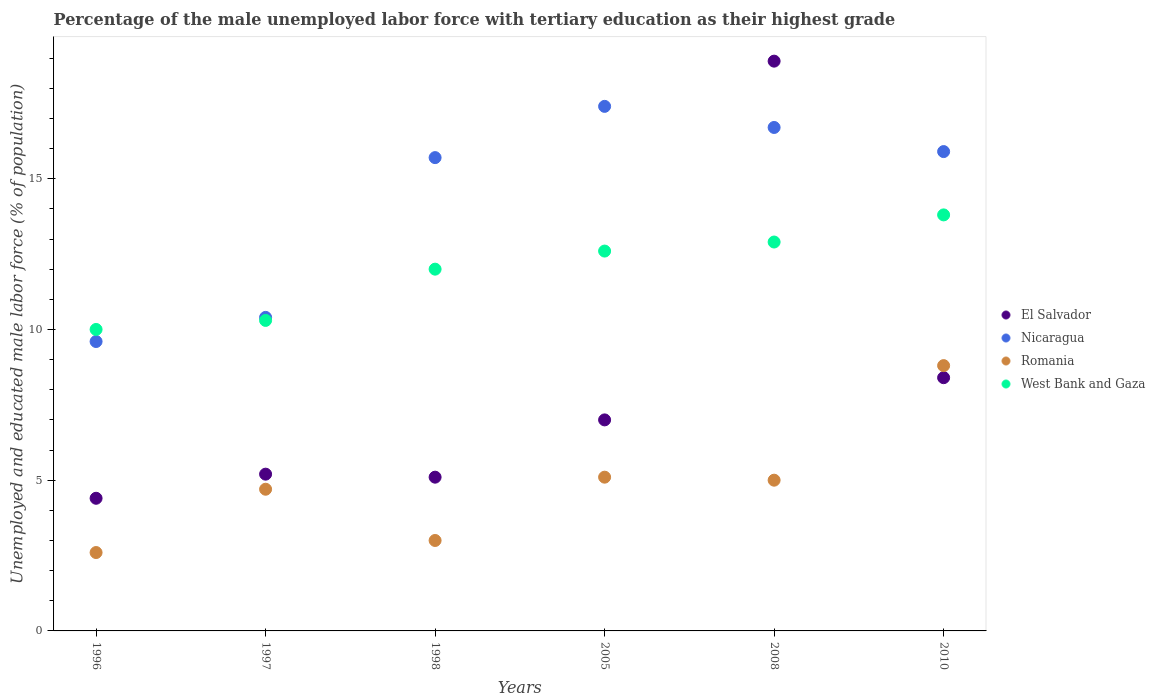How many different coloured dotlines are there?
Give a very brief answer. 4. What is the percentage of the unemployed male labor force with tertiary education in El Salvador in 2008?
Your response must be concise. 18.9. Across all years, what is the maximum percentage of the unemployed male labor force with tertiary education in Romania?
Give a very brief answer. 8.8. Across all years, what is the minimum percentage of the unemployed male labor force with tertiary education in El Salvador?
Make the answer very short. 4.4. In which year was the percentage of the unemployed male labor force with tertiary education in Romania minimum?
Your answer should be compact. 1996. What is the total percentage of the unemployed male labor force with tertiary education in Nicaragua in the graph?
Offer a very short reply. 85.7. What is the difference between the percentage of the unemployed male labor force with tertiary education in Romania in 1996 and that in 1998?
Provide a short and direct response. -0.4. What is the difference between the percentage of the unemployed male labor force with tertiary education in Nicaragua in 1997 and the percentage of the unemployed male labor force with tertiary education in El Salvador in 2005?
Your response must be concise. 3.4. What is the average percentage of the unemployed male labor force with tertiary education in West Bank and Gaza per year?
Provide a short and direct response. 11.93. In the year 1998, what is the difference between the percentage of the unemployed male labor force with tertiary education in West Bank and Gaza and percentage of the unemployed male labor force with tertiary education in El Salvador?
Offer a very short reply. 6.9. What is the ratio of the percentage of the unemployed male labor force with tertiary education in West Bank and Gaza in 1998 to that in 2010?
Offer a terse response. 0.87. Is the percentage of the unemployed male labor force with tertiary education in West Bank and Gaza in 1998 less than that in 2005?
Your answer should be compact. Yes. Is the difference between the percentage of the unemployed male labor force with tertiary education in West Bank and Gaza in 1998 and 2008 greater than the difference between the percentage of the unemployed male labor force with tertiary education in El Salvador in 1998 and 2008?
Give a very brief answer. Yes. What is the difference between the highest and the second highest percentage of the unemployed male labor force with tertiary education in Nicaragua?
Your response must be concise. 0.7. What is the difference between the highest and the lowest percentage of the unemployed male labor force with tertiary education in Nicaragua?
Your response must be concise. 7.8. Is the sum of the percentage of the unemployed male labor force with tertiary education in Romania in 1996 and 2010 greater than the maximum percentage of the unemployed male labor force with tertiary education in West Bank and Gaza across all years?
Give a very brief answer. No. Is it the case that in every year, the sum of the percentage of the unemployed male labor force with tertiary education in Nicaragua and percentage of the unemployed male labor force with tertiary education in Romania  is greater than the percentage of the unemployed male labor force with tertiary education in West Bank and Gaza?
Your response must be concise. Yes. How many dotlines are there?
Make the answer very short. 4. How many years are there in the graph?
Ensure brevity in your answer.  6. What is the difference between two consecutive major ticks on the Y-axis?
Your answer should be very brief. 5. Does the graph contain any zero values?
Your answer should be very brief. No. Does the graph contain grids?
Keep it short and to the point. No. Where does the legend appear in the graph?
Offer a terse response. Center right. What is the title of the graph?
Make the answer very short. Percentage of the male unemployed labor force with tertiary education as their highest grade. What is the label or title of the X-axis?
Offer a terse response. Years. What is the label or title of the Y-axis?
Provide a succinct answer. Unemployed and educated male labor force (% of population). What is the Unemployed and educated male labor force (% of population) of El Salvador in 1996?
Your response must be concise. 4.4. What is the Unemployed and educated male labor force (% of population) of Nicaragua in 1996?
Provide a short and direct response. 9.6. What is the Unemployed and educated male labor force (% of population) in Romania in 1996?
Your answer should be very brief. 2.6. What is the Unemployed and educated male labor force (% of population) in El Salvador in 1997?
Offer a terse response. 5.2. What is the Unemployed and educated male labor force (% of population) of Nicaragua in 1997?
Your answer should be compact. 10.4. What is the Unemployed and educated male labor force (% of population) in Romania in 1997?
Your answer should be very brief. 4.7. What is the Unemployed and educated male labor force (% of population) of West Bank and Gaza in 1997?
Provide a short and direct response. 10.3. What is the Unemployed and educated male labor force (% of population) in El Salvador in 1998?
Keep it short and to the point. 5.1. What is the Unemployed and educated male labor force (% of population) of Nicaragua in 1998?
Ensure brevity in your answer.  15.7. What is the Unemployed and educated male labor force (% of population) in Nicaragua in 2005?
Provide a succinct answer. 17.4. What is the Unemployed and educated male labor force (% of population) in Romania in 2005?
Your answer should be very brief. 5.1. What is the Unemployed and educated male labor force (% of population) in West Bank and Gaza in 2005?
Offer a very short reply. 12.6. What is the Unemployed and educated male labor force (% of population) of El Salvador in 2008?
Offer a terse response. 18.9. What is the Unemployed and educated male labor force (% of population) in Nicaragua in 2008?
Make the answer very short. 16.7. What is the Unemployed and educated male labor force (% of population) of Romania in 2008?
Your answer should be compact. 5. What is the Unemployed and educated male labor force (% of population) in West Bank and Gaza in 2008?
Keep it short and to the point. 12.9. What is the Unemployed and educated male labor force (% of population) in El Salvador in 2010?
Offer a terse response. 8.4. What is the Unemployed and educated male labor force (% of population) in Nicaragua in 2010?
Offer a very short reply. 15.9. What is the Unemployed and educated male labor force (% of population) in Romania in 2010?
Provide a short and direct response. 8.8. What is the Unemployed and educated male labor force (% of population) of West Bank and Gaza in 2010?
Offer a very short reply. 13.8. Across all years, what is the maximum Unemployed and educated male labor force (% of population) of El Salvador?
Give a very brief answer. 18.9. Across all years, what is the maximum Unemployed and educated male labor force (% of population) in Nicaragua?
Provide a short and direct response. 17.4. Across all years, what is the maximum Unemployed and educated male labor force (% of population) in Romania?
Keep it short and to the point. 8.8. Across all years, what is the maximum Unemployed and educated male labor force (% of population) in West Bank and Gaza?
Provide a short and direct response. 13.8. Across all years, what is the minimum Unemployed and educated male labor force (% of population) in El Salvador?
Your answer should be very brief. 4.4. Across all years, what is the minimum Unemployed and educated male labor force (% of population) in Nicaragua?
Keep it short and to the point. 9.6. Across all years, what is the minimum Unemployed and educated male labor force (% of population) in Romania?
Provide a succinct answer. 2.6. Across all years, what is the minimum Unemployed and educated male labor force (% of population) in West Bank and Gaza?
Your response must be concise. 10. What is the total Unemployed and educated male labor force (% of population) of Nicaragua in the graph?
Give a very brief answer. 85.7. What is the total Unemployed and educated male labor force (% of population) in Romania in the graph?
Make the answer very short. 29.2. What is the total Unemployed and educated male labor force (% of population) in West Bank and Gaza in the graph?
Your answer should be compact. 71.6. What is the difference between the Unemployed and educated male labor force (% of population) in El Salvador in 1996 and that in 1997?
Ensure brevity in your answer.  -0.8. What is the difference between the Unemployed and educated male labor force (% of population) of Romania in 1996 and that in 1997?
Offer a terse response. -2.1. What is the difference between the Unemployed and educated male labor force (% of population) of West Bank and Gaza in 1996 and that in 1997?
Offer a very short reply. -0.3. What is the difference between the Unemployed and educated male labor force (% of population) in El Salvador in 1996 and that in 1998?
Your answer should be compact. -0.7. What is the difference between the Unemployed and educated male labor force (% of population) of Nicaragua in 1996 and that in 1998?
Your answer should be very brief. -6.1. What is the difference between the Unemployed and educated male labor force (% of population) in Romania in 1996 and that in 1998?
Offer a very short reply. -0.4. What is the difference between the Unemployed and educated male labor force (% of population) in West Bank and Gaza in 1996 and that in 1998?
Offer a very short reply. -2. What is the difference between the Unemployed and educated male labor force (% of population) in El Salvador in 1996 and that in 2005?
Provide a short and direct response. -2.6. What is the difference between the Unemployed and educated male labor force (% of population) in El Salvador in 1996 and that in 2008?
Your response must be concise. -14.5. What is the difference between the Unemployed and educated male labor force (% of population) of Nicaragua in 1996 and that in 2008?
Offer a very short reply. -7.1. What is the difference between the Unemployed and educated male labor force (% of population) of West Bank and Gaza in 1996 and that in 2008?
Give a very brief answer. -2.9. What is the difference between the Unemployed and educated male labor force (% of population) in El Salvador in 1997 and that in 1998?
Your answer should be compact. 0.1. What is the difference between the Unemployed and educated male labor force (% of population) in Nicaragua in 1997 and that in 1998?
Ensure brevity in your answer.  -5.3. What is the difference between the Unemployed and educated male labor force (% of population) of Romania in 1997 and that in 1998?
Your answer should be very brief. 1.7. What is the difference between the Unemployed and educated male labor force (% of population) of West Bank and Gaza in 1997 and that in 1998?
Your response must be concise. -1.7. What is the difference between the Unemployed and educated male labor force (% of population) in El Salvador in 1997 and that in 2005?
Make the answer very short. -1.8. What is the difference between the Unemployed and educated male labor force (% of population) of El Salvador in 1997 and that in 2008?
Provide a succinct answer. -13.7. What is the difference between the Unemployed and educated male labor force (% of population) in West Bank and Gaza in 1997 and that in 2008?
Give a very brief answer. -2.6. What is the difference between the Unemployed and educated male labor force (% of population) of Nicaragua in 1997 and that in 2010?
Your answer should be compact. -5.5. What is the difference between the Unemployed and educated male labor force (% of population) in West Bank and Gaza in 1997 and that in 2010?
Provide a succinct answer. -3.5. What is the difference between the Unemployed and educated male labor force (% of population) in El Salvador in 1998 and that in 2008?
Offer a terse response. -13.8. What is the difference between the Unemployed and educated male labor force (% of population) in West Bank and Gaza in 1998 and that in 2008?
Provide a short and direct response. -0.9. What is the difference between the Unemployed and educated male labor force (% of population) of El Salvador in 1998 and that in 2010?
Offer a terse response. -3.3. What is the difference between the Unemployed and educated male labor force (% of population) of El Salvador in 2005 and that in 2008?
Ensure brevity in your answer.  -11.9. What is the difference between the Unemployed and educated male labor force (% of population) in Romania in 2005 and that in 2010?
Offer a terse response. -3.7. What is the difference between the Unemployed and educated male labor force (% of population) of Nicaragua in 2008 and that in 2010?
Give a very brief answer. 0.8. What is the difference between the Unemployed and educated male labor force (% of population) of Romania in 2008 and that in 2010?
Your answer should be compact. -3.8. What is the difference between the Unemployed and educated male labor force (% of population) of El Salvador in 1996 and the Unemployed and educated male labor force (% of population) of Nicaragua in 1997?
Offer a very short reply. -6. What is the difference between the Unemployed and educated male labor force (% of population) in El Salvador in 1996 and the Unemployed and educated male labor force (% of population) in West Bank and Gaza in 1997?
Ensure brevity in your answer.  -5.9. What is the difference between the Unemployed and educated male labor force (% of population) in Nicaragua in 1996 and the Unemployed and educated male labor force (% of population) in Romania in 1997?
Your response must be concise. 4.9. What is the difference between the Unemployed and educated male labor force (% of population) in El Salvador in 1996 and the Unemployed and educated male labor force (% of population) in Nicaragua in 1998?
Ensure brevity in your answer.  -11.3. What is the difference between the Unemployed and educated male labor force (% of population) in El Salvador in 1996 and the Unemployed and educated male labor force (% of population) in Romania in 1998?
Your response must be concise. 1.4. What is the difference between the Unemployed and educated male labor force (% of population) in Nicaragua in 1996 and the Unemployed and educated male labor force (% of population) in Romania in 1998?
Offer a terse response. 6.6. What is the difference between the Unemployed and educated male labor force (% of population) of Romania in 1996 and the Unemployed and educated male labor force (% of population) of West Bank and Gaza in 1998?
Provide a succinct answer. -9.4. What is the difference between the Unemployed and educated male labor force (% of population) in El Salvador in 1996 and the Unemployed and educated male labor force (% of population) in Romania in 2008?
Your response must be concise. -0.6. What is the difference between the Unemployed and educated male labor force (% of population) in El Salvador in 1996 and the Unemployed and educated male labor force (% of population) in West Bank and Gaza in 2008?
Offer a very short reply. -8.5. What is the difference between the Unemployed and educated male labor force (% of population) in Romania in 1996 and the Unemployed and educated male labor force (% of population) in West Bank and Gaza in 2008?
Provide a succinct answer. -10.3. What is the difference between the Unemployed and educated male labor force (% of population) in El Salvador in 1996 and the Unemployed and educated male labor force (% of population) in Nicaragua in 2010?
Provide a succinct answer. -11.5. What is the difference between the Unemployed and educated male labor force (% of population) in El Salvador in 1996 and the Unemployed and educated male labor force (% of population) in Romania in 2010?
Make the answer very short. -4.4. What is the difference between the Unemployed and educated male labor force (% of population) of Nicaragua in 1996 and the Unemployed and educated male labor force (% of population) of West Bank and Gaza in 2010?
Provide a succinct answer. -4.2. What is the difference between the Unemployed and educated male labor force (% of population) in El Salvador in 1997 and the Unemployed and educated male labor force (% of population) in Romania in 1998?
Keep it short and to the point. 2.2. What is the difference between the Unemployed and educated male labor force (% of population) in El Salvador in 1997 and the Unemployed and educated male labor force (% of population) in West Bank and Gaza in 1998?
Ensure brevity in your answer.  -6.8. What is the difference between the Unemployed and educated male labor force (% of population) in Nicaragua in 1997 and the Unemployed and educated male labor force (% of population) in Romania in 1998?
Offer a very short reply. 7.4. What is the difference between the Unemployed and educated male labor force (% of population) in El Salvador in 1997 and the Unemployed and educated male labor force (% of population) in Romania in 2005?
Offer a very short reply. 0.1. What is the difference between the Unemployed and educated male labor force (% of population) of El Salvador in 1997 and the Unemployed and educated male labor force (% of population) of West Bank and Gaza in 2005?
Offer a very short reply. -7.4. What is the difference between the Unemployed and educated male labor force (% of population) of El Salvador in 1997 and the Unemployed and educated male labor force (% of population) of Nicaragua in 2008?
Make the answer very short. -11.5. What is the difference between the Unemployed and educated male labor force (% of population) of El Salvador in 1997 and the Unemployed and educated male labor force (% of population) of Romania in 2008?
Offer a terse response. 0.2. What is the difference between the Unemployed and educated male labor force (% of population) in El Salvador in 1997 and the Unemployed and educated male labor force (% of population) in West Bank and Gaza in 2008?
Make the answer very short. -7.7. What is the difference between the Unemployed and educated male labor force (% of population) of Nicaragua in 1997 and the Unemployed and educated male labor force (% of population) of Romania in 2008?
Provide a succinct answer. 5.4. What is the difference between the Unemployed and educated male labor force (% of population) in El Salvador in 1997 and the Unemployed and educated male labor force (% of population) in Romania in 2010?
Offer a terse response. -3.6. What is the difference between the Unemployed and educated male labor force (% of population) in El Salvador in 1998 and the Unemployed and educated male labor force (% of population) in Nicaragua in 2005?
Your answer should be compact. -12.3. What is the difference between the Unemployed and educated male labor force (% of population) in El Salvador in 1998 and the Unemployed and educated male labor force (% of population) in Romania in 2008?
Your response must be concise. 0.1. What is the difference between the Unemployed and educated male labor force (% of population) of El Salvador in 1998 and the Unemployed and educated male labor force (% of population) of West Bank and Gaza in 2008?
Ensure brevity in your answer.  -7.8. What is the difference between the Unemployed and educated male labor force (% of population) of Romania in 1998 and the Unemployed and educated male labor force (% of population) of West Bank and Gaza in 2008?
Ensure brevity in your answer.  -9.9. What is the difference between the Unemployed and educated male labor force (% of population) of El Salvador in 1998 and the Unemployed and educated male labor force (% of population) of West Bank and Gaza in 2010?
Provide a succinct answer. -8.7. What is the difference between the Unemployed and educated male labor force (% of population) in Nicaragua in 1998 and the Unemployed and educated male labor force (% of population) in Romania in 2010?
Ensure brevity in your answer.  6.9. What is the difference between the Unemployed and educated male labor force (% of population) of Nicaragua in 1998 and the Unemployed and educated male labor force (% of population) of West Bank and Gaza in 2010?
Offer a very short reply. 1.9. What is the difference between the Unemployed and educated male labor force (% of population) in El Salvador in 2005 and the Unemployed and educated male labor force (% of population) in Nicaragua in 2008?
Your answer should be compact. -9.7. What is the difference between the Unemployed and educated male labor force (% of population) of Nicaragua in 2005 and the Unemployed and educated male labor force (% of population) of Romania in 2008?
Your answer should be compact. 12.4. What is the difference between the Unemployed and educated male labor force (% of population) of Romania in 2005 and the Unemployed and educated male labor force (% of population) of West Bank and Gaza in 2008?
Offer a very short reply. -7.8. What is the difference between the Unemployed and educated male labor force (% of population) of El Salvador in 2005 and the Unemployed and educated male labor force (% of population) of Nicaragua in 2010?
Offer a terse response. -8.9. What is the difference between the Unemployed and educated male labor force (% of population) of Nicaragua in 2005 and the Unemployed and educated male labor force (% of population) of Romania in 2010?
Your answer should be very brief. 8.6. What is the difference between the Unemployed and educated male labor force (% of population) of Nicaragua in 2005 and the Unemployed and educated male labor force (% of population) of West Bank and Gaza in 2010?
Provide a succinct answer. 3.6. What is the difference between the Unemployed and educated male labor force (% of population) in El Salvador in 2008 and the Unemployed and educated male labor force (% of population) in Nicaragua in 2010?
Give a very brief answer. 3. What is the difference between the Unemployed and educated male labor force (% of population) in El Salvador in 2008 and the Unemployed and educated male labor force (% of population) in Romania in 2010?
Give a very brief answer. 10.1. What is the difference between the Unemployed and educated male labor force (% of population) in El Salvador in 2008 and the Unemployed and educated male labor force (% of population) in West Bank and Gaza in 2010?
Make the answer very short. 5.1. What is the difference between the Unemployed and educated male labor force (% of population) in Romania in 2008 and the Unemployed and educated male labor force (% of population) in West Bank and Gaza in 2010?
Keep it short and to the point. -8.8. What is the average Unemployed and educated male labor force (% of population) in El Salvador per year?
Your response must be concise. 8.17. What is the average Unemployed and educated male labor force (% of population) in Nicaragua per year?
Ensure brevity in your answer.  14.28. What is the average Unemployed and educated male labor force (% of population) in Romania per year?
Make the answer very short. 4.87. What is the average Unemployed and educated male labor force (% of population) of West Bank and Gaza per year?
Offer a very short reply. 11.93. In the year 1996, what is the difference between the Unemployed and educated male labor force (% of population) of El Salvador and Unemployed and educated male labor force (% of population) of Nicaragua?
Offer a very short reply. -5.2. In the year 1996, what is the difference between the Unemployed and educated male labor force (% of population) of El Salvador and Unemployed and educated male labor force (% of population) of Romania?
Ensure brevity in your answer.  1.8. In the year 1996, what is the difference between the Unemployed and educated male labor force (% of population) of El Salvador and Unemployed and educated male labor force (% of population) of West Bank and Gaza?
Provide a short and direct response. -5.6. In the year 1996, what is the difference between the Unemployed and educated male labor force (% of population) in Nicaragua and Unemployed and educated male labor force (% of population) in West Bank and Gaza?
Keep it short and to the point. -0.4. In the year 1996, what is the difference between the Unemployed and educated male labor force (% of population) in Romania and Unemployed and educated male labor force (% of population) in West Bank and Gaza?
Your response must be concise. -7.4. In the year 1998, what is the difference between the Unemployed and educated male labor force (% of population) in El Salvador and Unemployed and educated male labor force (% of population) in Romania?
Give a very brief answer. 2.1. In the year 1998, what is the difference between the Unemployed and educated male labor force (% of population) in El Salvador and Unemployed and educated male labor force (% of population) in West Bank and Gaza?
Keep it short and to the point. -6.9. In the year 1998, what is the difference between the Unemployed and educated male labor force (% of population) of Romania and Unemployed and educated male labor force (% of population) of West Bank and Gaza?
Offer a very short reply. -9. In the year 2005, what is the difference between the Unemployed and educated male labor force (% of population) in El Salvador and Unemployed and educated male labor force (% of population) in Nicaragua?
Make the answer very short. -10.4. In the year 2005, what is the difference between the Unemployed and educated male labor force (% of population) in El Salvador and Unemployed and educated male labor force (% of population) in Romania?
Ensure brevity in your answer.  1.9. In the year 2005, what is the difference between the Unemployed and educated male labor force (% of population) in El Salvador and Unemployed and educated male labor force (% of population) in West Bank and Gaza?
Keep it short and to the point. -5.6. In the year 2005, what is the difference between the Unemployed and educated male labor force (% of population) in Nicaragua and Unemployed and educated male labor force (% of population) in West Bank and Gaza?
Your answer should be compact. 4.8. In the year 2005, what is the difference between the Unemployed and educated male labor force (% of population) in Romania and Unemployed and educated male labor force (% of population) in West Bank and Gaza?
Give a very brief answer. -7.5. In the year 2008, what is the difference between the Unemployed and educated male labor force (% of population) of El Salvador and Unemployed and educated male labor force (% of population) of Nicaragua?
Offer a terse response. 2.2. In the year 2008, what is the difference between the Unemployed and educated male labor force (% of population) of El Salvador and Unemployed and educated male labor force (% of population) of Romania?
Provide a succinct answer. 13.9. In the year 2010, what is the difference between the Unemployed and educated male labor force (% of population) in El Salvador and Unemployed and educated male labor force (% of population) in Nicaragua?
Your answer should be very brief. -7.5. In the year 2010, what is the difference between the Unemployed and educated male labor force (% of population) in El Salvador and Unemployed and educated male labor force (% of population) in Romania?
Your response must be concise. -0.4. In the year 2010, what is the difference between the Unemployed and educated male labor force (% of population) of Romania and Unemployed and educated male labor force (% of population) of West Bank and Gaza?
Your answer should be compact. -5. What is the ratio of the Unemployed and educated male labor force (% of population) of El Salvador in 1996 to that in 1997?
Make the answer very short. 0.85. What is the ratio of the Unemployed and educated male labor force (% of population) of Nicaragua in 1996 to that in 1997?
Give a very brief answer. 0.92. What is the ratio of the Unemployed and educated male labor force (% of population) of Romania in 1996 to that in 1997?
Offer a very short reply. 0.55. What is the ratio of the Unemployed and educated male labor force (% of population) of West Bank and Gaza in 1996 to that in 1997?
Ensure brevity in your answer.  0.97. What is the ratio of the Unemployed and educated male labor force (% of population) of El Salvador in 1996 to that in 1998?
Ensure brevity in your answer.  0.86. What is the ratio of the Unemployed and educated male labor force (% of population) in Nicaragua in 1996 to that in 1998?
Your answer should be compact. 0.61. What is the ratio of the Unemployed and educated male labor force (% of population) in Romania in 1996 to that in 1998?
Ensure brevity in your answer.  0.87. What is the ratio of the Unemployed and educated male labor force (% of population) of El Salvador in 1996 to that in 2005?
Offer a very short reply. 0.63. What is the ratio of the Unemployed and educated male labor force (% of population) in Nicaragua in 1996 to that in 2005?
Provide a short and direct response. 0.55. What is the ratio of the Unemployed and educated male labor force (% of population) of Romania in 1996 to that in 2005?
Keep it short and to the point. 0.51. What is the ratio of the Unemployed and educated male labor force (% of population) in West Bank and Gaza in 1996 to that in 2005?
Your answer should be very brief. 0.79. What is the ratio of the Unemployed and educated male labor force (% of population) of El Salvador in 1996 to that in 2008?
Give a very brief answer. 0.23. What is the ratio of the Unemployed and educated male labor force (% of population) in Nicaragua in 1996 to that in 2008?
Provide a short and direct response. 0.57. What is the ratio of the Unemployed and educated male labor force (% of population) in Romania in 1996 to that in 2008?
Make the answer very short. 0.52. What is the ratio of the Unemployed and educated male labor force (% of population) in West Bank and Gaza in 1996 to that in 2008?
Ensure brevity in your answer.  0.78. What is the ratio of the Unemployed and educated male labor force (% of population) of El Salvador in 1996 to that in 2010?
Give a very brief answer. 0.52. What is the ratio of the Unemployed and educated male labor force (% of population) of Nicaragua in 1996 to that in 2010?
Provide a short and direct response. 0.6. What is the ratio of the Unemployed and educated male labor force (% of population) in Romania in 1996 to that in 2010?
Offer a very short reply. 0.3. What is the ratio of the Unemployed and educated male labor force (% of population) of West Bank and Gaza in 1996 to that in 2010?
Provide a succinct answer. 0.72. What is the ratio of the Unemployed and educated male labor force (% of population) of El Salvador in 1997 to that in 1998?
Ensure brevity in your answer.  1.02. What is the ratio of the Unemployed and educated male labor force (% of population) in Nicaragua in 1997 to that in 1998?
Provide a short and direct response. 0.66. What is the ratio of the Unemployed and educated male labor force (% of population) of Romania in 1997 to that in 1998?
Ensure brevity in your answer.  1.57. What is the ratio of the Unemployed and educated male labor force (% of population) in West Bank and Gaza in 1997 to that in 1998?
Keep it short and to the point. 0.86. What is the ratio of the Unemployed and educated male labor force (% of population) in El Salvador in 1997 to that in 2005?
Keep it short and to the point. 0.74. What is the ratio of the Unemployed and educated male labor force (% of population) of Nicaragua in 1997 to that in 2005?
Your answer should be compact. 0.6. What is the ratio of the Unemployed and educated male labor force (% of population) in Romania in 1997 to that in 2005?
Your response must be concise. 0.92. What is the ratio of the Unemployed and educated male labor force (% of population) of West Bank and Gaza in 1997 to that in 2005?
Give a very brief answer. 0.82. What is the ratio of the Unemployed and educated male labor force (% of population) in El Salvador in 1997 to that in 2008?
Provide a short and direct response. 0.28. What is the ratio of the Unemployed and educated male labor force (% of population) of Nicaragua in 1997 to that in 2008?
Provide a short and direct response. 0.62. What is the ratio of the Unemployed and educated male labor force (% of population) of Romania in 1997 to that in 2008?
Make the answer very short. 0.94. What is the ratio of the Unemployed and educated male labor force (% of population) in West Bank and Gaza in 1997 to that in 2008?
Provide a short and direct response. 0.8. What is the ratio of the Unemployed and educated male labor force (% of population) in El Salvador in 1997 to that in 2010?
Make the answer very short. 0.62. What is the ratio of the Unemployed and educated male labor force (% of population) in Nicaragua in 1997 to that in 2010?
Provide a succinct answer. 0.65. What is the ratio of the Unemployed and educated male labor force (% of population) in Romania in 1997 to that in 2010?
Provide a succinct answer. 0.53. What is the ratio of the Unemployed and educated male labor force (% of population) in West Bank and Gaza in 1997 to that in 2010?
Make the answer very short. 0.75. What is the ratio of the Unemployed and educated male labor force (% of population) in El Salvador in 1998 to that in 2005?
Your answer should be compact. 0.73. What is the ratio of the Unemployed and educated male labor force (% of population) in Nicaragua in 1998 to that in 2005?
Offer a very short reply. 0.9. What is the ratio of the Unemployed and educated male labor force (% of population) in Romania in 1998 to that in 2005?
Provide a short and direct response. 0.59. What is the ratio of the Unemployed and educated male labor force (% of population) in El Salvador in 1998 to that in 2008?
Provide a short and direct response. 0.27. What is the ratio of the Unemployed and educated male labor force (% of population) in Nicaragua in 1998 to that in 2008?
Offer a terse response. 0.94. What is the ratio of the Unemployed and educated male labor force (% of population) in Romania in 1998 to that in 2008?
Provide a short and direct response. 0.6. What is the ratio of the Unemployed and educated male labor force (% of population) of West Bank and Gaza in 1998 to that in 2008?
Keep it short and to the point. 0.93. What is the ratio of the Unemployed and educated male labor force (% of population) in El Salvador in 1998 to that in 2010?
Make the answer very short. 0.61. What is the ratio of the Unemployed and educated male labor force (% of population) of Nicaragua in 1998 to that in 2010?
Give a very brief answer. 0.99. What is the ratio of the Unemployed and educated male labor force (% of population) in Romania in 1998 to that in 2010?
Offer a terse response. 0.34. What is the ratio of the Unemployed and educated male labor force (% of population) in West Bank and Gaza in 1998 to that in 2010?
Provide a short and direct response. 0.87. What is the ratio of the Unemployed and educated male labor force (% of population) in El Salvador in 2005 to that in 2008?
Ensure brevity in your answer.  0.37. What is the ratio of the Unemployed and educated male labor force (% of population) in Nicaragua in 2005 to that in 2008?
Offer a terse response. 1.04. What is the ratio of the Unemployed and educated male labor force (% of population) in West Bank and Gaza in 2005 to that in 2008?
Keep it short and to the point. 0.98. What is the ratio of the Unemployed and educated male labor force (% of population) of Nicaragua in 2005 to that in 2010?
Keep it short and to the point. 1.09. What is the ratio of the Unemployed and educated male labor force (% of population) of Romania in 2005 to that in 2010?
Your answer should be compact. 0.58. What is the ratio of the Unemployed and educated male labor force (% of population) in El Salvador in 2008 to that in 2010?
Offer a terse response. 2.25. What is the ratio of the Unemployed and educated male labor force (% of population) in Nicaragua in 2008 to that in 2010?
Your response must be concise. 1.05. What is the ratio of the Unemployed and educated male labor force (% of population) in Romania in 2008 to that in 2010?
Keep it short and to the point. 0.57. What is the ratio of the Unemployed and educated male labor force (% of population) in West Bank and Gaza in 2008 to that in 2010?
Your answer should be very brief. 0.93. What is the difference between the highest and the second highest Unemployed and educated male labor force (% of population) in El Salvador?
Your answer should be compact. 10.5. What is the difference between the highest and the second highest Unemployed and educated male labor force (% of population) of Nicaragua?
Give a very brief answer. 0.7. What is the difference between the highest and the second highest Unemployed and educated male labor force (% of population) in Romania?
Provide a short and direct response. 3.7. What is the difference between the highest and the second highest Unemployed and educated male labor force (% of population) in West Bank and Gaza?
Make the answer very short. 0.9. What is the difference between the highest and the lowest Unemployed and educated male labor force (% of population) in Nicaragua?
Your answer should be very brief. 7.8. 